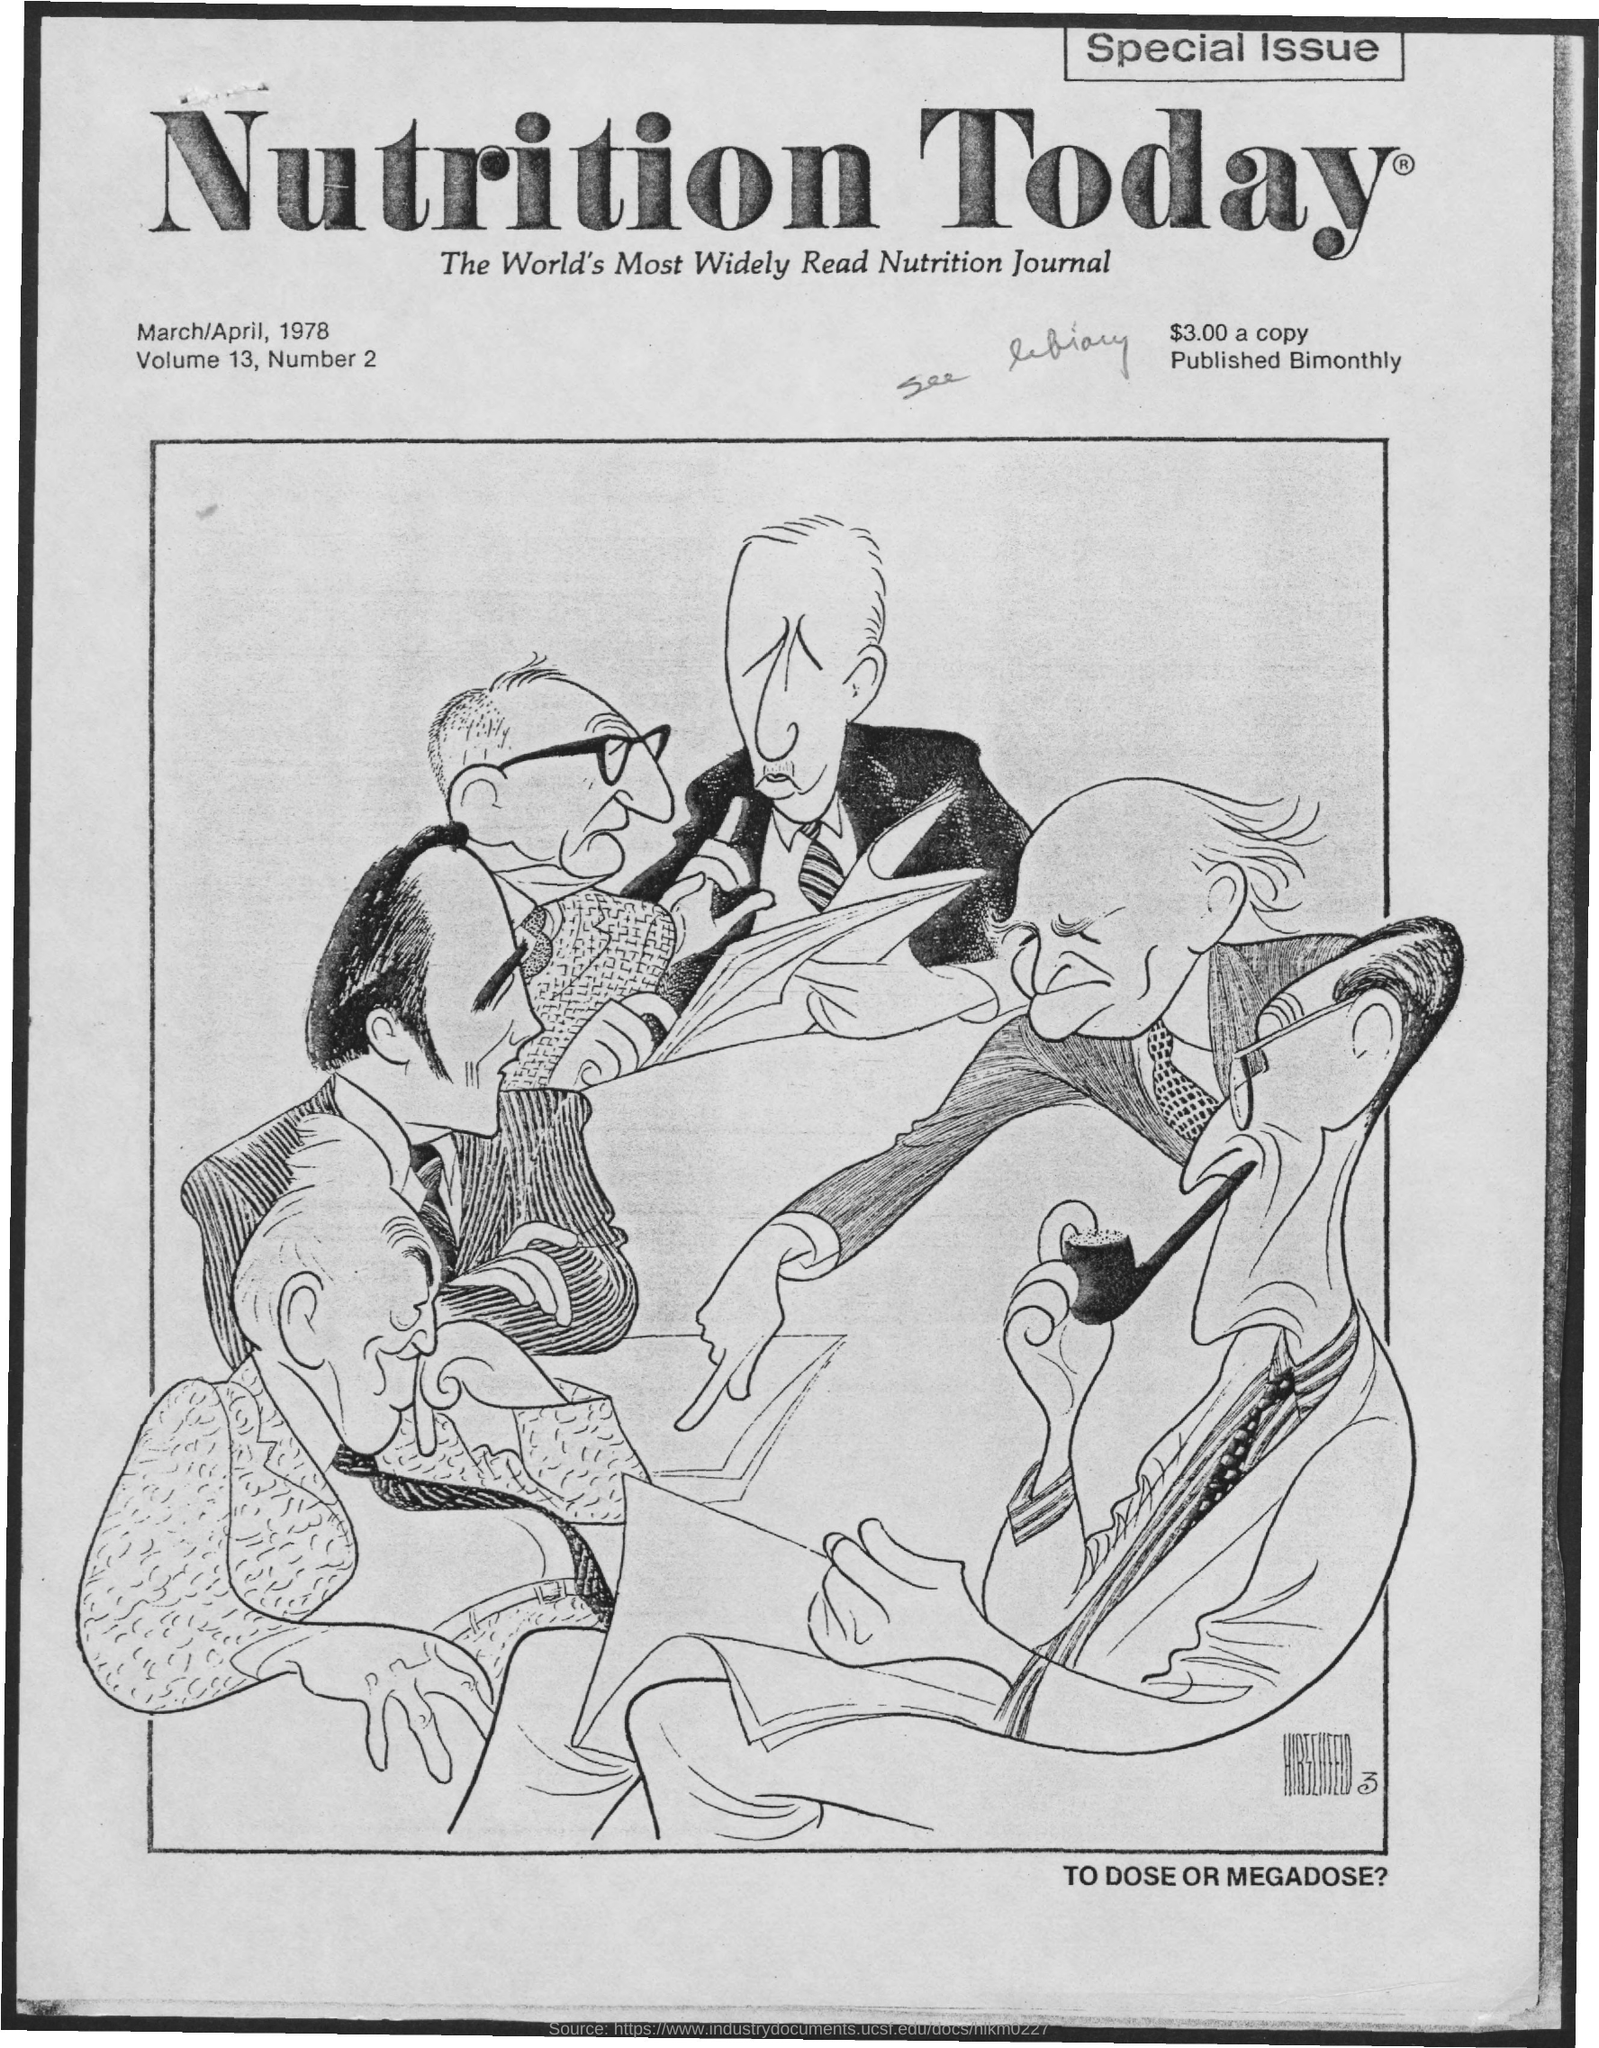What is the Title of the document?
Give a very brief answer. Nutrition Today. What is the Volume?
Offer a very short reply. 13. What is the Number?
Provide a succinct answer. 2. How often is it published?
Your response must be concise. Bimonthly. 